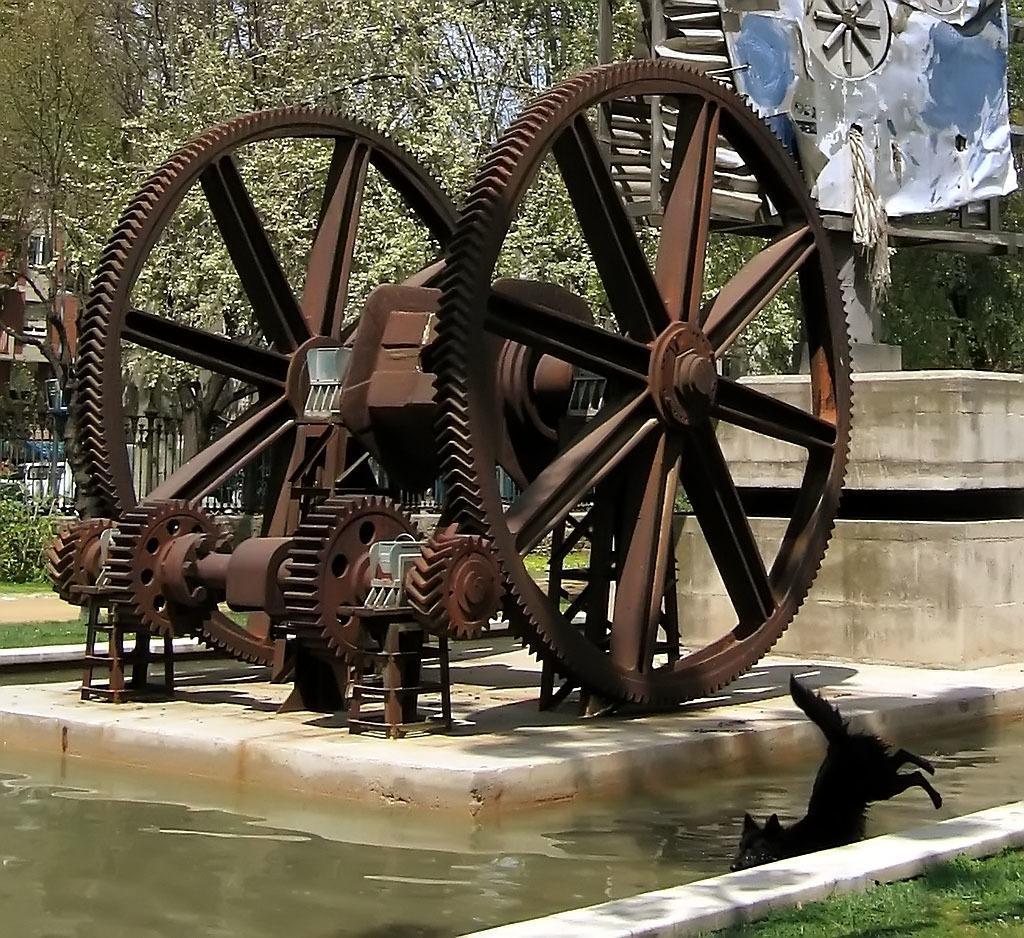Could you give a brief overview of what you see in this image? In this picture I can see a mechanical instrument with wheels. I can see an animal jumping into the water. I can see iron grilles, vehicle, plants, building, trees and some other objects. 